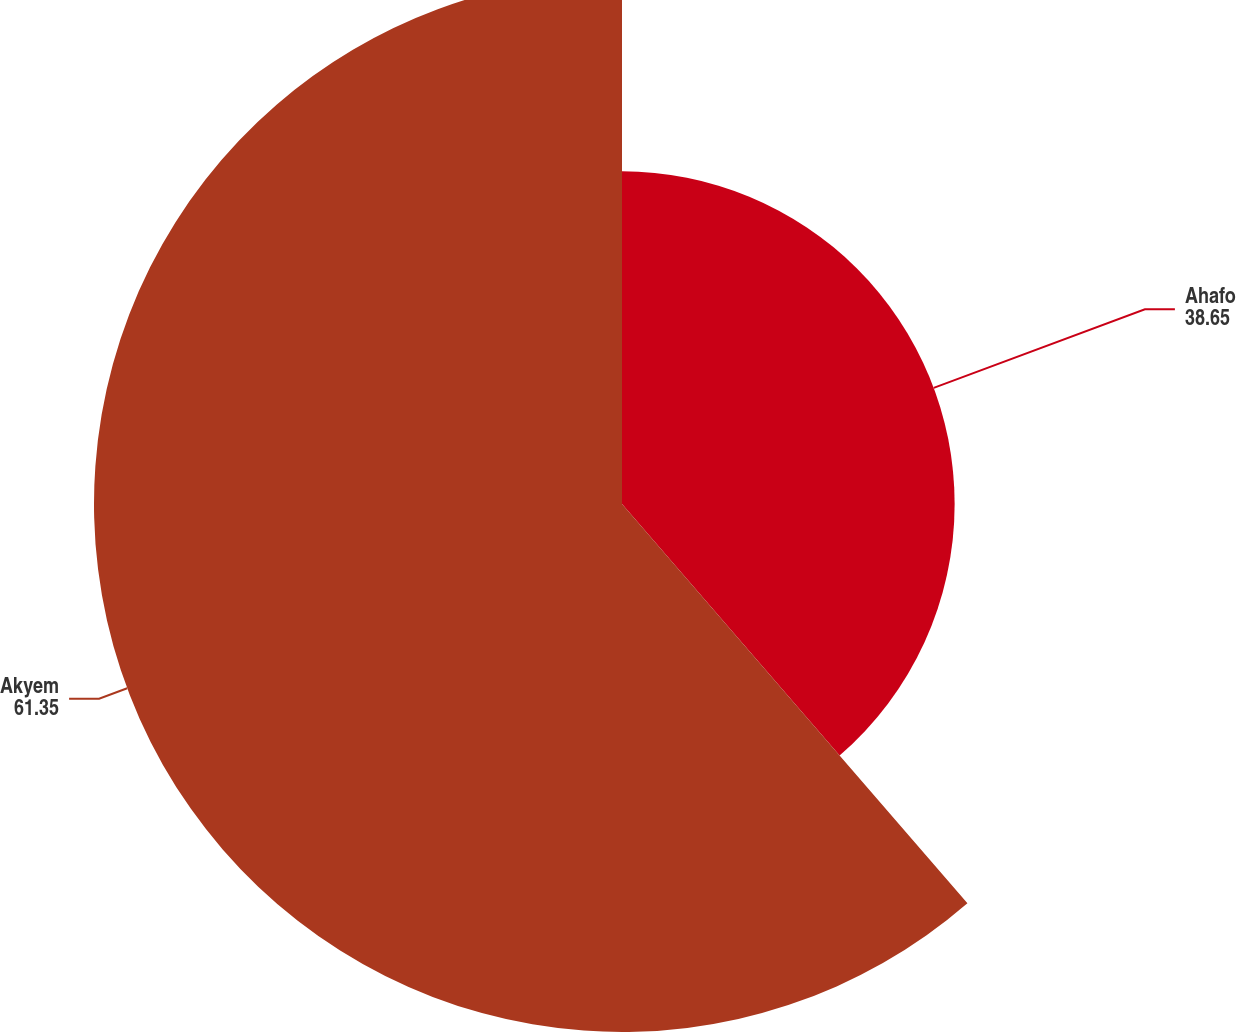<chart> <loc_0><loc_0><loc_500><loc_500><pie_chart><fcel>Ahafo<fcel>Akyem<nl><fcel>38.65%<fcel>61.35%<nl></chart> 